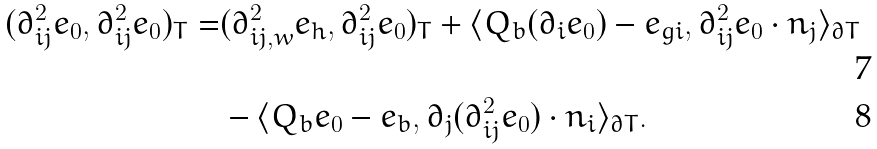<formula> <loc_0><loc_0><loc_500><loc_500>( \partial ^ { 2 } _ { i j } e _ { 0 } , \partial ^ { 2 } _ { i j } e _ { 0 } ) _ { T } = & ( \partial ^ { 2 } _ { i j , w } e _ { h } , \partial ^ { 2 } _ { i j } e _ { 0 } ) _ { T } + \langle Q _ { b } ( \partial _ { i } e _ { 0 } ) - e _ { g i } , \partial ^ { 2 } _ { i j } e _ { 0 } \cdot n _ { j } \rangle _ { \partial T } \\ & - \langle Q _ { b } e _ { 0 } - e _ { b } , \partial _ { j } ( \partial ^ { 2 } _ { i j } e _ { 0 } ) \cdot n _ { i } \rangle _ { \partial T } .</formula> 